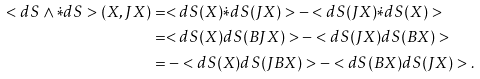<formula> <loc_0><loc_0><loc_500><loc_500>< d S \wedge \dot { * } d S > ( X , J X ) & = < d S ( X ) \dot { * } d S ( J X ) > - < d S ( J X ) \dot { * } d S ( X ) > \\ & = < d S ( X ) d S ( B J X ) > - < d S ( J X ) d S ( B X ) > \\ & = - < d S ( X ) d S ( J B X ) > - < d S ( B X ) d S ( J X ) > .</formula> 